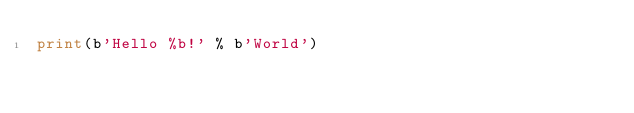Convert code to text. <code><loc_0><loc_0><loc_500><loc_500><_Python_>print(b'Hello %b!' % b'World')</code> 